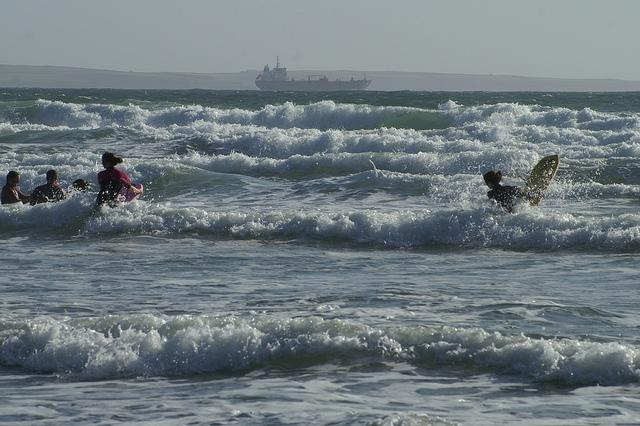What activity is taking place besides surfing? swimming 